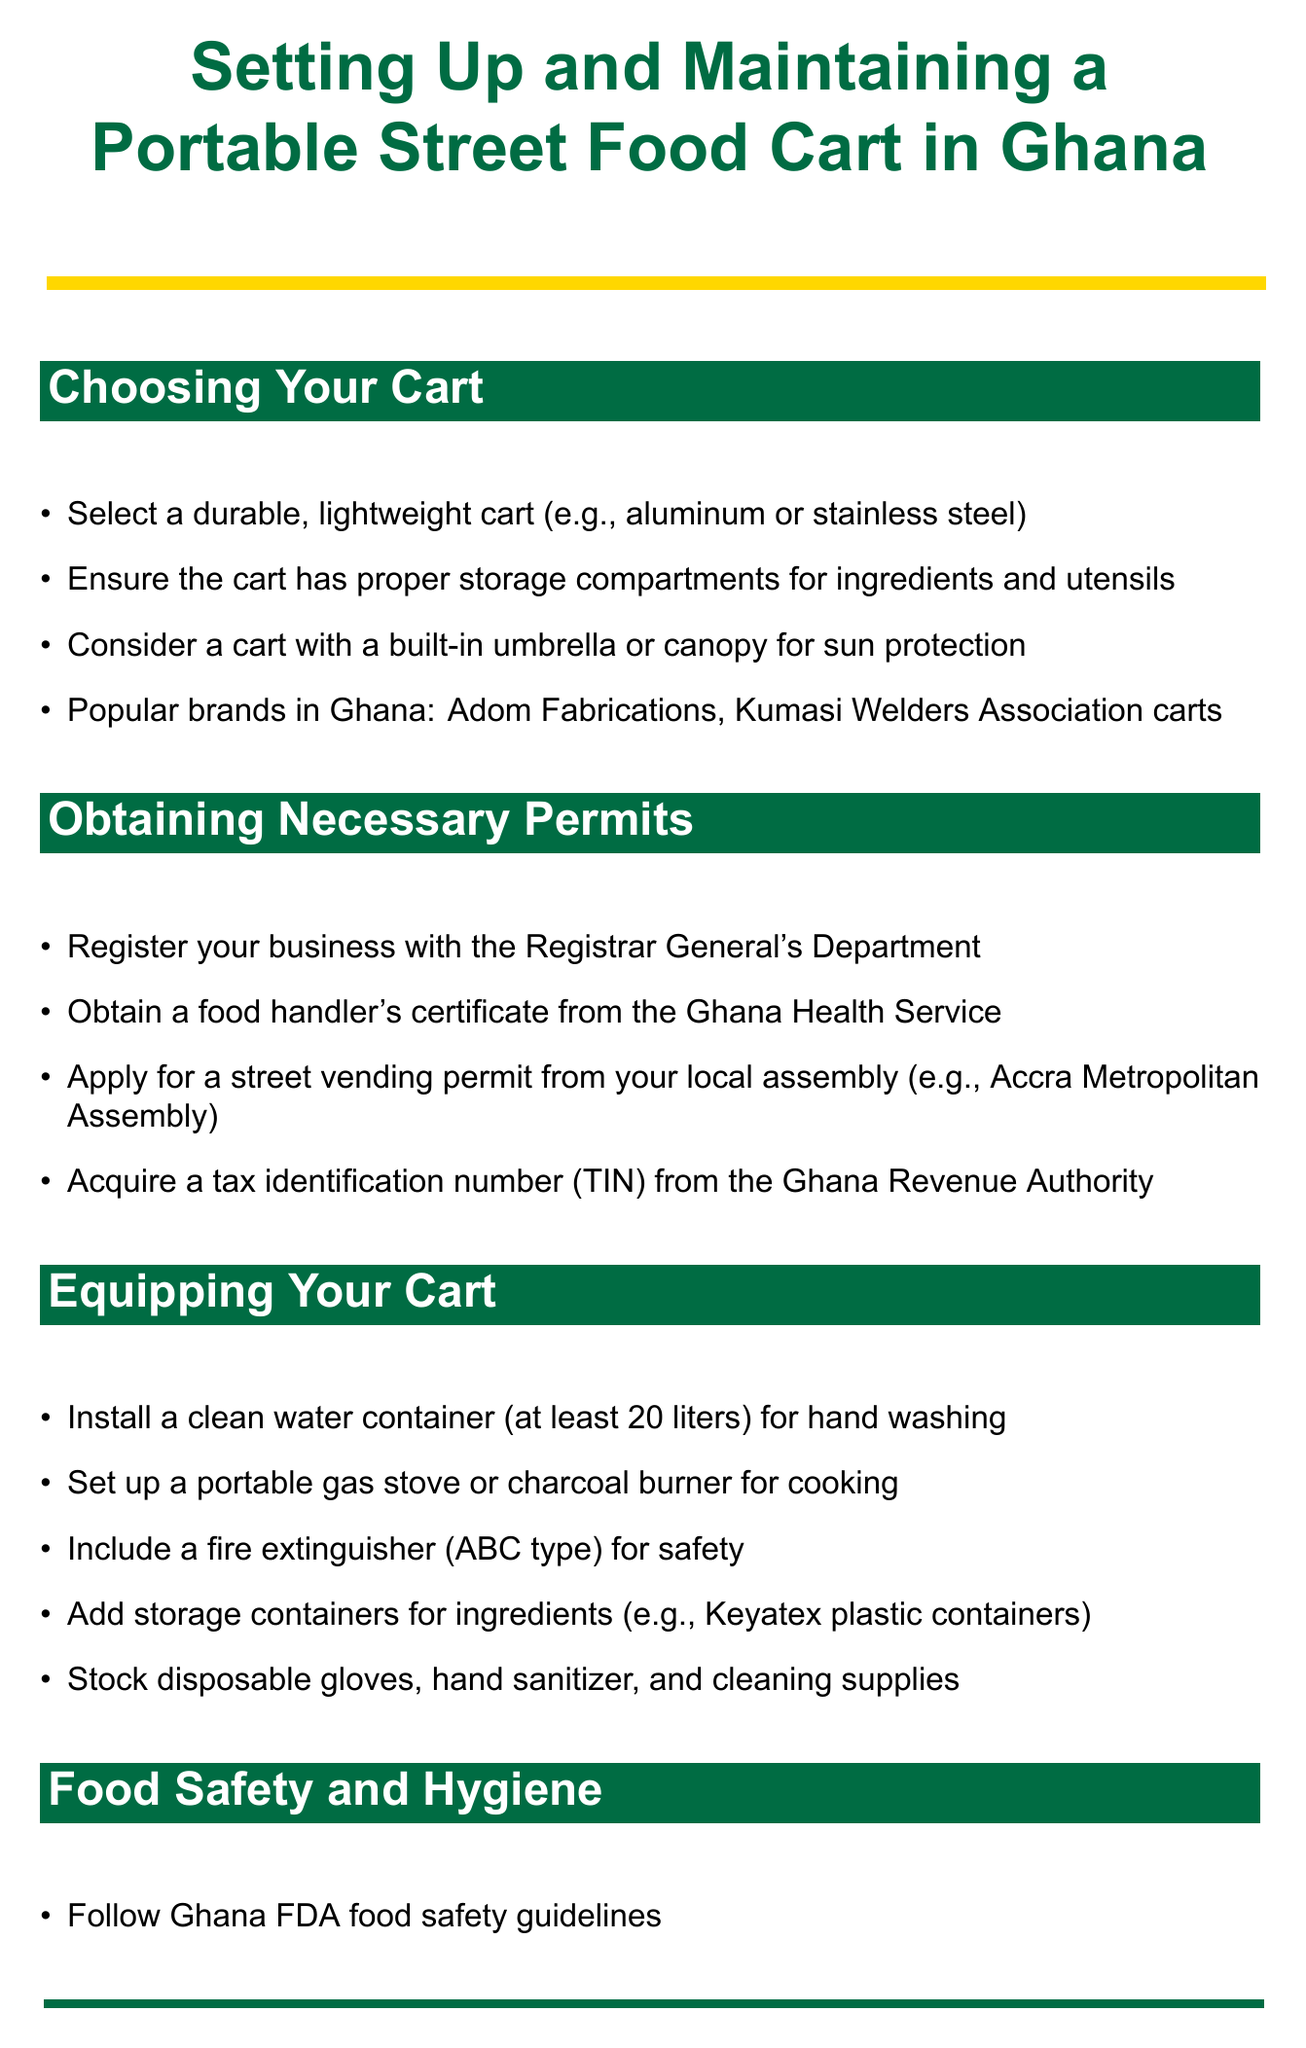what materials should the cart be made of? The document states that the cart should be made of durable, lightweight materials like aluminum or stainless steel.
Answer: aluminum or stainless steel what permit is required for food handling? The manual specifies that one must obtain a food handler's certificate from the Ghana Health Service.
Answer: food handler's certificate how much clean water capacity should the container have? The document advises installing a clean water container with at least a specific capacity for hand washing.
Answer: 20 liters which popular Ghanaian street food is mentioned? Among the examples given, waakye is highlighted as a popular street food.
Answer: waakye what type of fire extinguisher is recommended? The manual recommends using an ABC type fire extinguisher for safety reasons.
Answer: ABC type what waste management strategy is suggested? The document advocates for providing a trash bin for customers as part of waste management.
Answer: trash bin where can ingredients be sourced from? The document indicates that ingredients should be sourced from local markets, mentioning Makola Market as an example.
Answer: Makola Market what payment methods should be accepted? It recommends accepting both cash and mobile money payments from customers.
Answer: cash and mobile money what is an important aspect of daily operations? The document mentions that displaying the food handler's certificate visibly is crucial during daily operations.
Answer: display food handler's certificate 